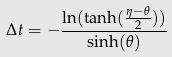<formula> <loc_0><loc_0><loc_500><loc_500>\Delta t = - \frac { \ln ( \tanh ( \frac { \eta - \theta } { 2 } ) ) } { \sinh ( \theta ) }</formula> 